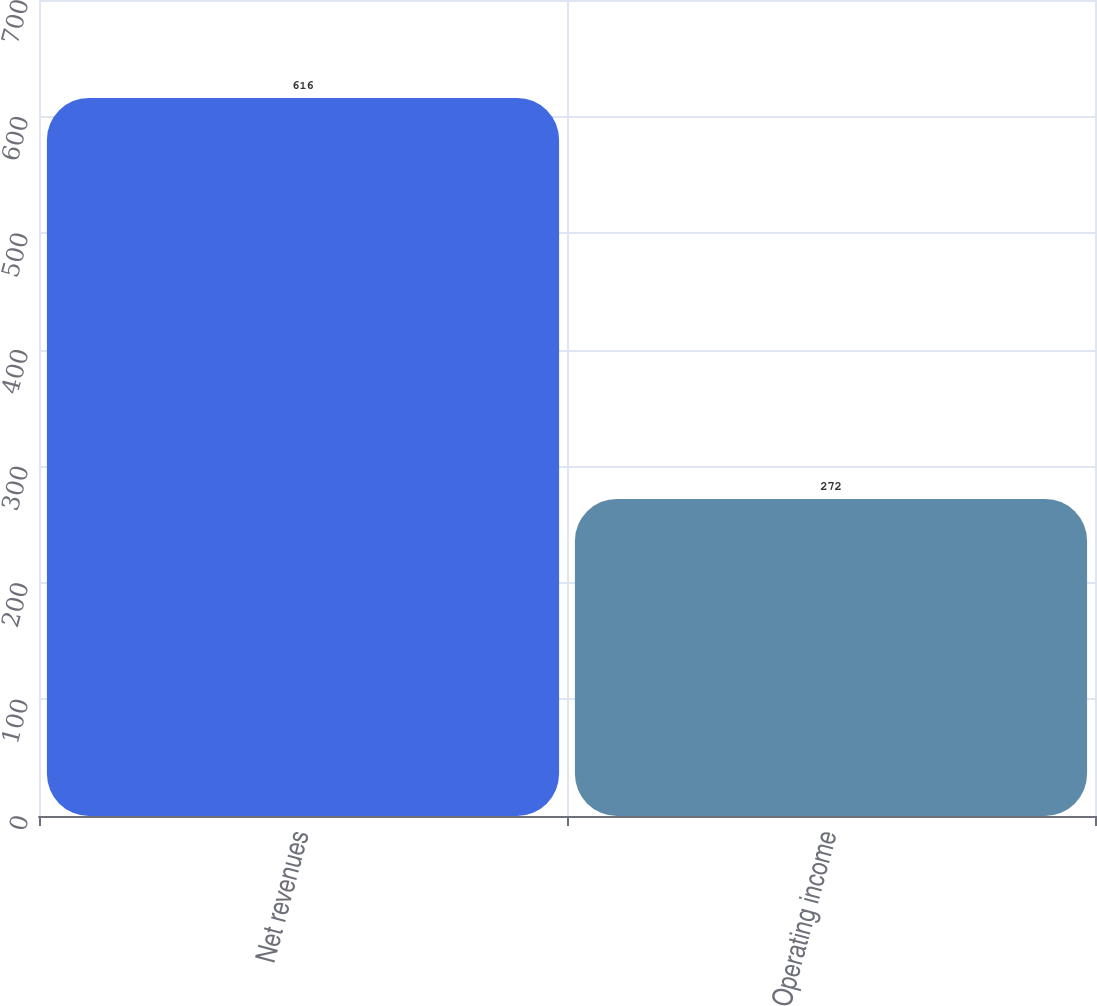Convert chart. <chart><loc_0><loc_0><loc_500><loc_500><bar_chart><fcel>Net revenues<fcel>Operating income<nl><fcel>616<fcel>272<nl></chart> 